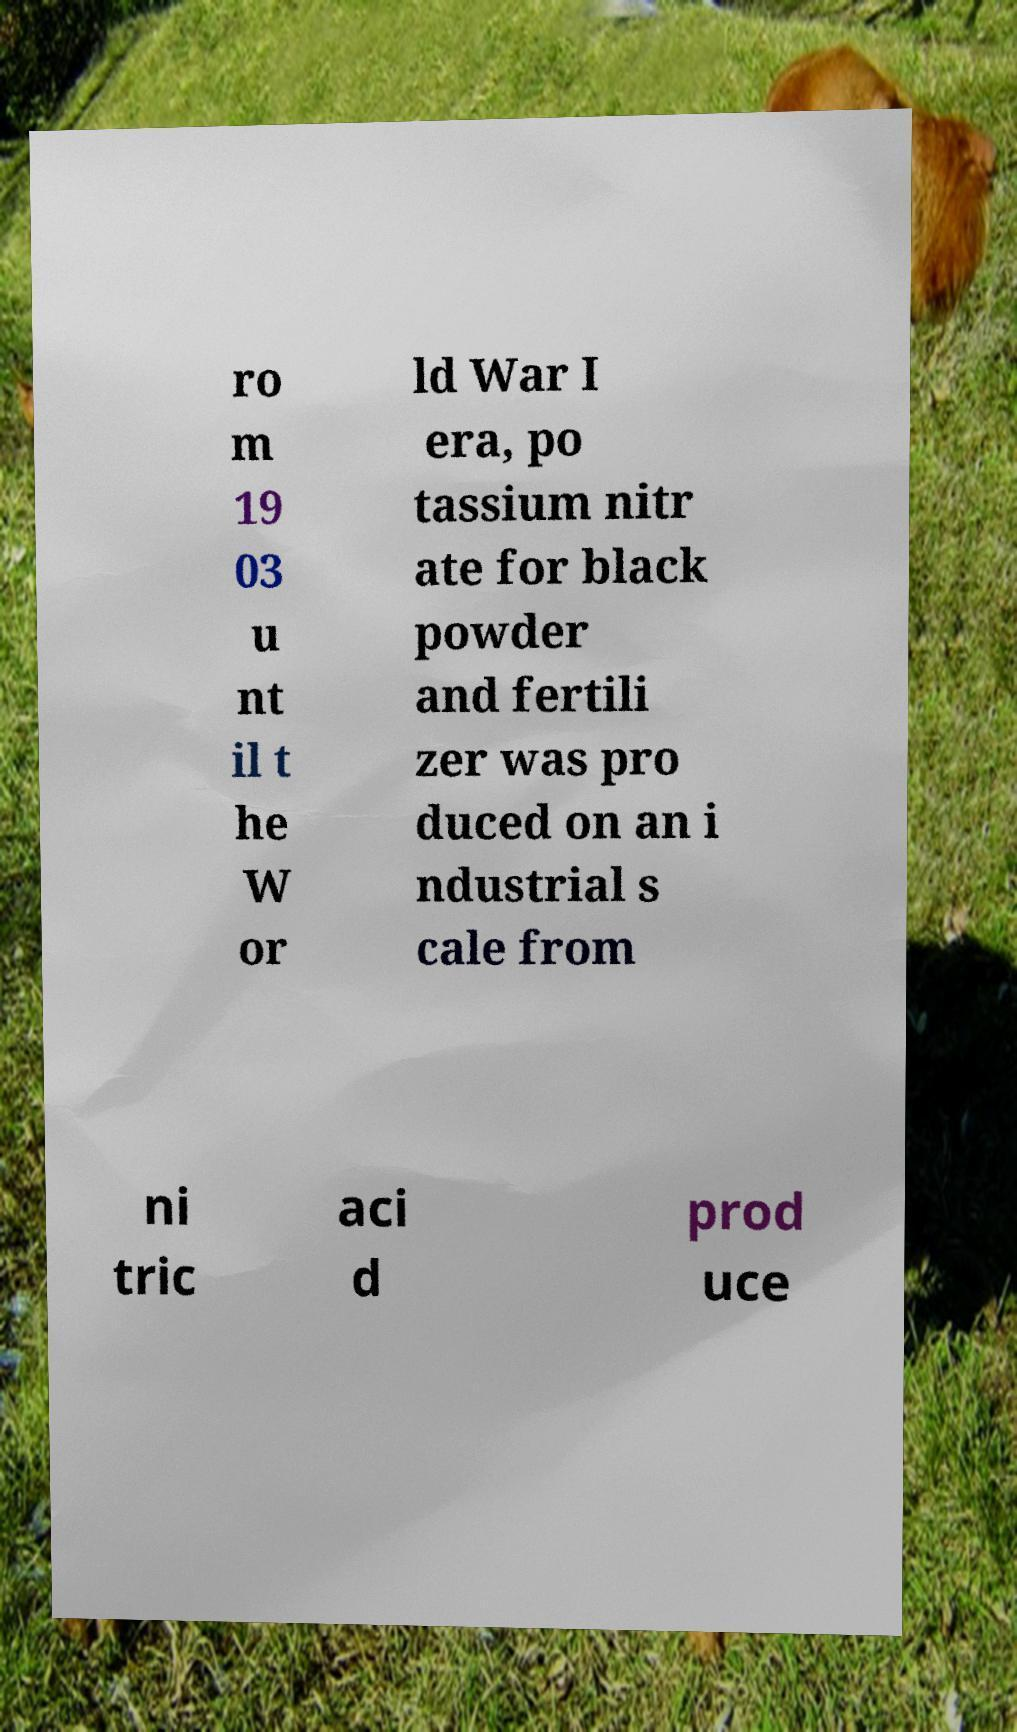For documentation purposes, I need the text within this image transcribed. Could you provide that? ro m 19 03 u nt il t he W or ld War I era, po tassium nitr ate for black powder and fertili zer was pro duced on an i ndustrial s cale from ni tric aci d prod uce 